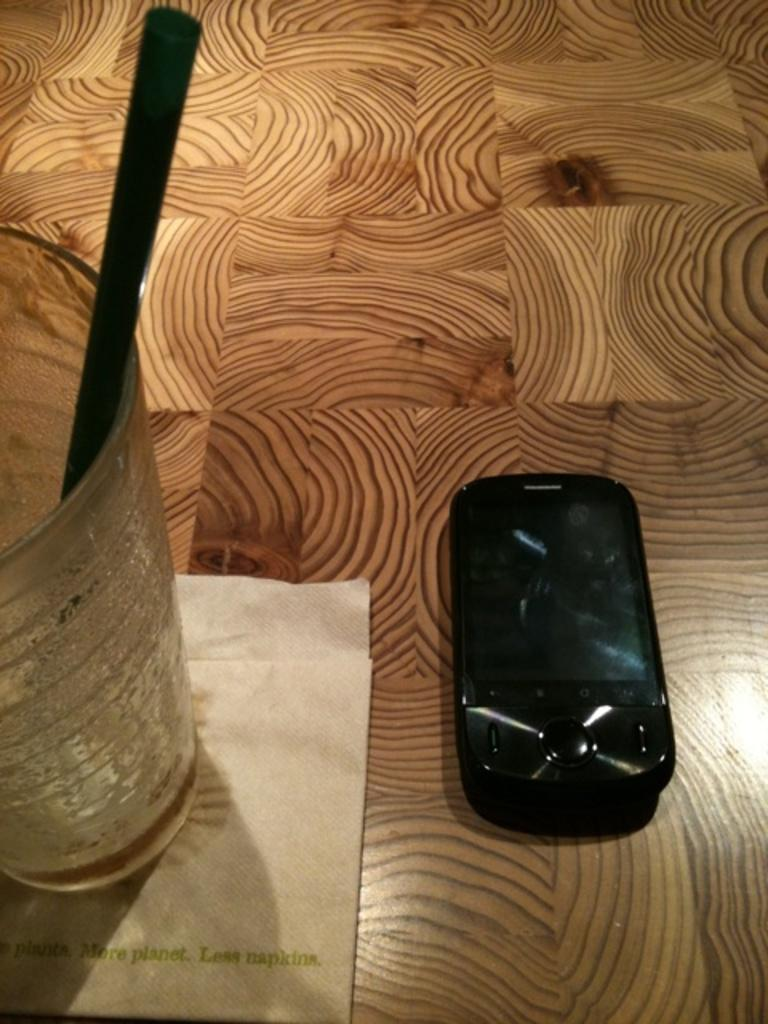<image>
Share a concise interpretation of the image provided. An electronic device by a glass sitting on a napkin that says less napkins. 